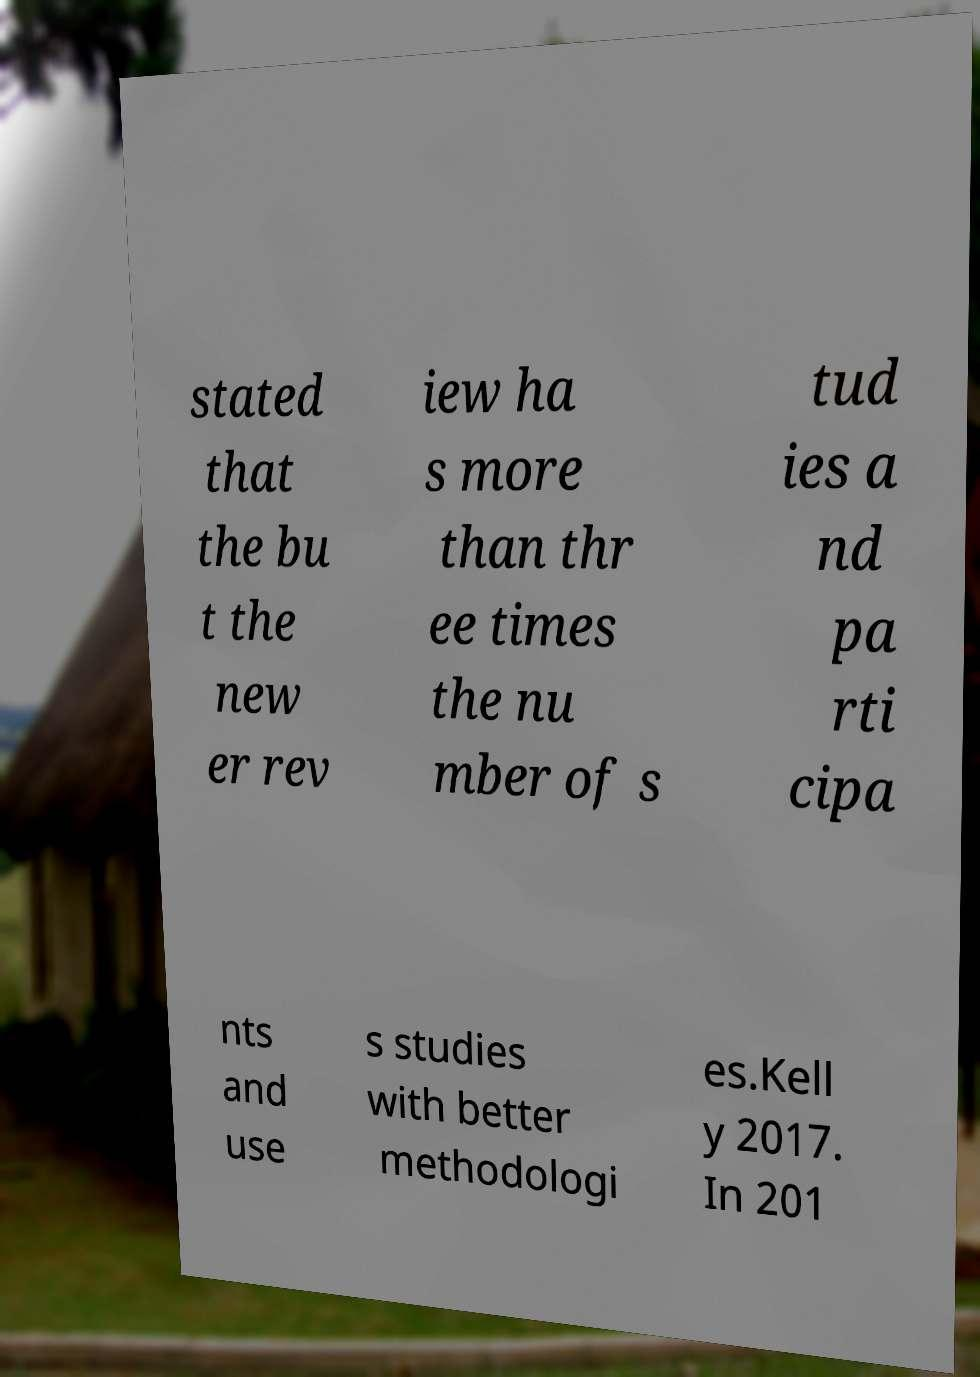What messages or text are displayed in this image? I need them in a readable, typed format. stated that the bu t the new er rev iew ha s more than thr ee times the nu mber of s tud ies a nd pa rti cipa nts and use s studies with better methodologi es.Kell y 2017. In 201 